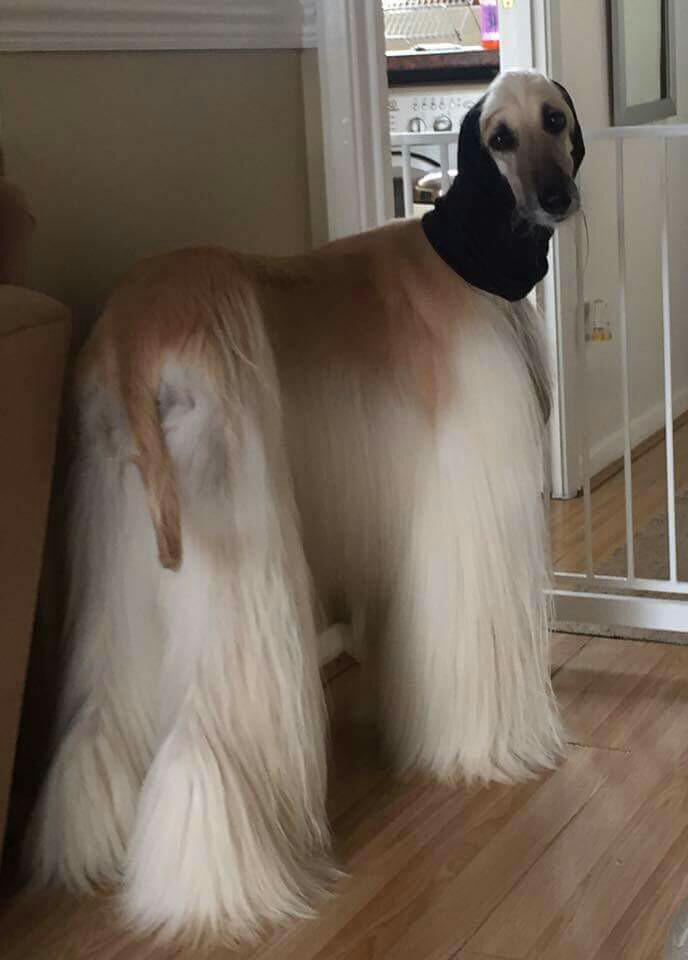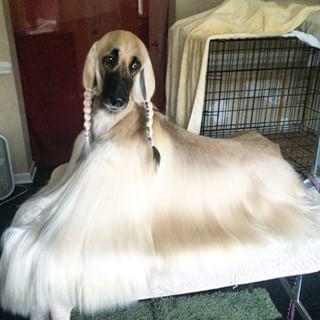The first image is the image on the left, the second image is the image on the right. Examine the images to the left and right. Is the description "One image shows a single afghan hound lying on a soft material with a print pattern in the scene, and the other image shows one forward-facing afghan with parted hair." accurate? Answer yes or no. No. The first image is the image on the left, the second image is the image on the right. Analyze the images presented: Is the assertion "One dog is standing and one dog is laying down." valid? Answer yes or no. Yes. 